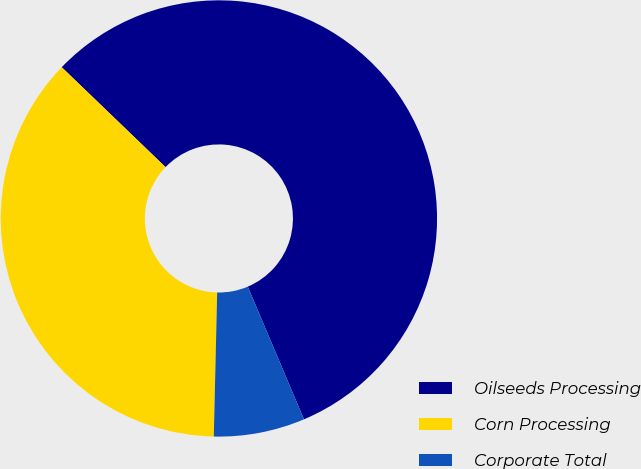<chart> <loc_0><loc_0><loc_500><loc_500><pie_chart><fcel>Oilseeds Processing<fcel>Corn Processing<fcel>Corporate Total<nl><fcel>56.43%<fcel>36.82%<fcel>6.75%<nl></chart> 